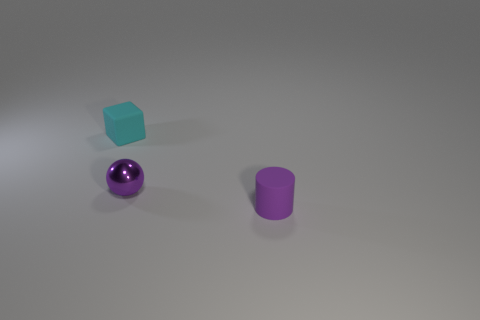What number of things are tiny objects behind the purple cylinder or matte things?
Provide a short and direct response. 3. Is the shape of the tiny cyan matte thing the same as the purple metal object?
Offer a terse response. No. What number of other things are the same size as the purple cylinder?
Your answer should be compact. 2. What color is the cube?
Provide a short and direct response. Cyan. What number of small things are green cylinders or cyan cubes?
Provide a succinct answer. 1. There is a matte object on the right side of the small cyan object; is its size the same as the thing that is behind the metal object?
Ensure brevity in your answer.  Yes. Is the number of tiny cubes that are behind the cyan object greater than the number of cyan rubber objects to the right of the purple shiny sphere?
Offer a very short reply. No. What material is the tiny thing that is both right of the cyan object and behind the small purple cylinder?
Ensure brevity in your answer.  Metal. The purple ball is what size?
Offer a terse response. Small. What color is the matte thing behind the small matte thing that is in front of the tiny cyan block?
Ensure brevity in your answer.  Cyan. 